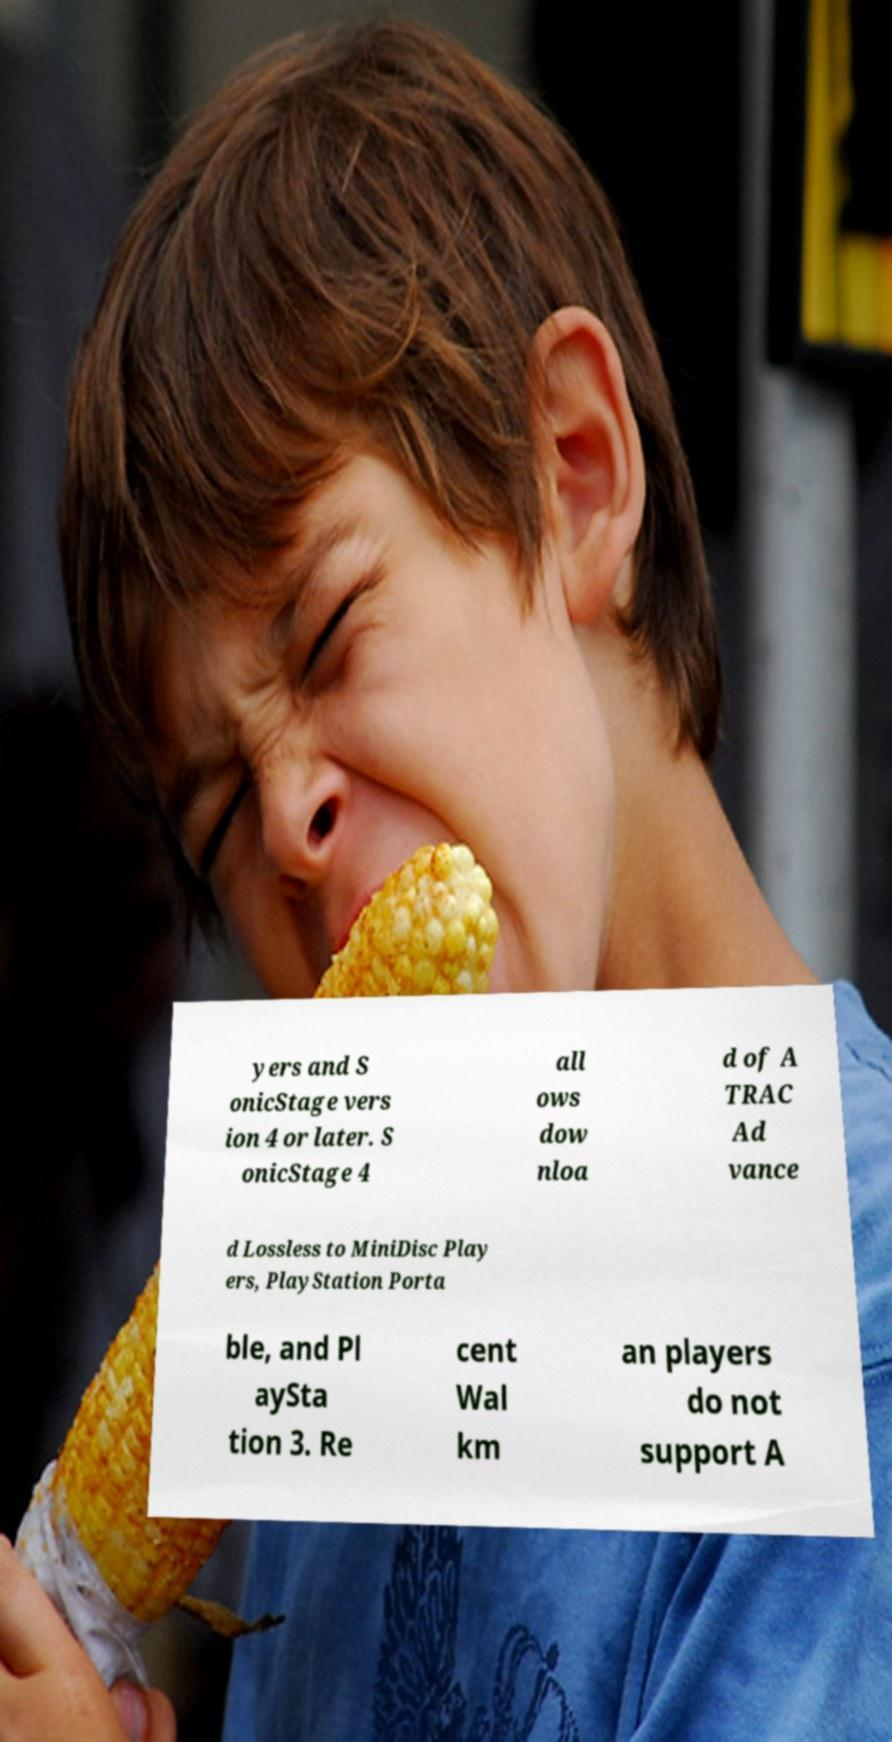I need the written content from this picture converted into text. Can you do that? yers and S onicStage vers ion 4 or later. S onicStage 4 all ows dow nloa d of A TRAC Ad vance d Lossless to MiniDisc Play ers, PlayStation Porta ble, and Pl aySta tion 3. Re cent Wal km an players do not support A 